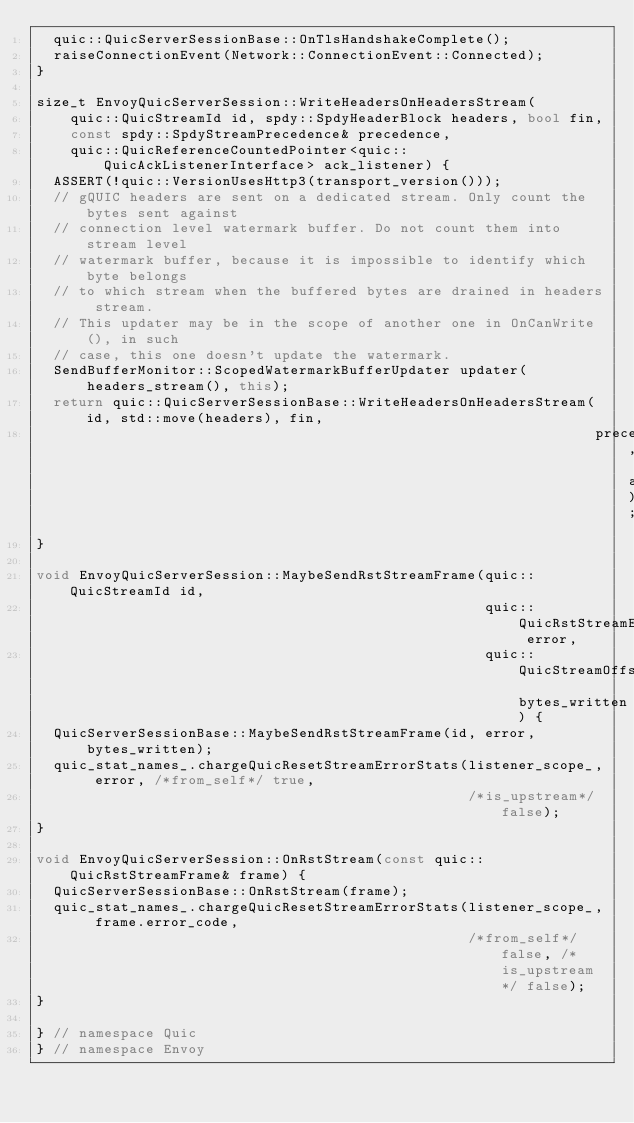<code> <loc_0><loc_0><loc_500><loc_500><_C++_>  quic::QuicServerSessionBase::OnTlsHandshakeComplete();
  raiseConnectionEvent(Network::ConnectionEvent::Connected);
}

size_t EnvoyQuicServerSession::WriteHeadersOnHeadersStream(
    quic::QuicStreamId id, spdy::SpdyHeaderBlock headers, bool fin,
    const spdy::SpdyStreamPrecedence& precedence,
    quic::QuicReferenceCountedPointer<quic::QuicAckListenerInterface> ack_listener) {
  ASSERT(!quic::VersionUsesHttp3(transport_version()));
  // gQUIC headers are sent on a dedicated stream. Only count the bytes sent against
  // connection level watermark buffer. Do not count them into stream level
  // watermark buffer, because it is impossible to identify which byte belongs
  // to which stream when the buffered bytes are drained in headers stream.
  // This updater may be in the scope of another one in OnCanWrite(), in such
  // case, this one doesn't update the watermark.
  SendBufferMonitor::ScopedWatermarkBufferUpdater updater(headers_stream(), this);
  return quic::QuicServerSessionBase::WriteHeadersOnHeadersStream(id, std::move(headers), fin,
                                                                  precedence, ack_listener);
}

void EnvoyQuicServerSession::MaybeSendRstStreamFrame(quic::QuicStreamId id,
                                                     quic::QuicRstStreamErrorCode error,
                                                     quic::QuicStreamOffset bytes_written) {
  QuicServerSessionBase::MaybeSendRstStreamFrame(id, error, bytes_written);
  quic_stat_names_.chargeQuicResetStreamErrorStats(listener_scope_, error, /*from_self*/ true,
                                                   /*is_upstream*/ false);
}

void EnvoyQuicServerSession::OnRstStream(const quic::QuicRstStreamFrame& frame) {
  QuicServerSessionBase::OnRstStream(frame);
  quic_stat_names_.chargeQuicResetStreamErrorStats(listener_scope_, frame.error_code,
                                                   /*from_self*/ false, /*is_upstream*/ false);
}

} // namespace Quic
} // namespace Envoy
</code> 